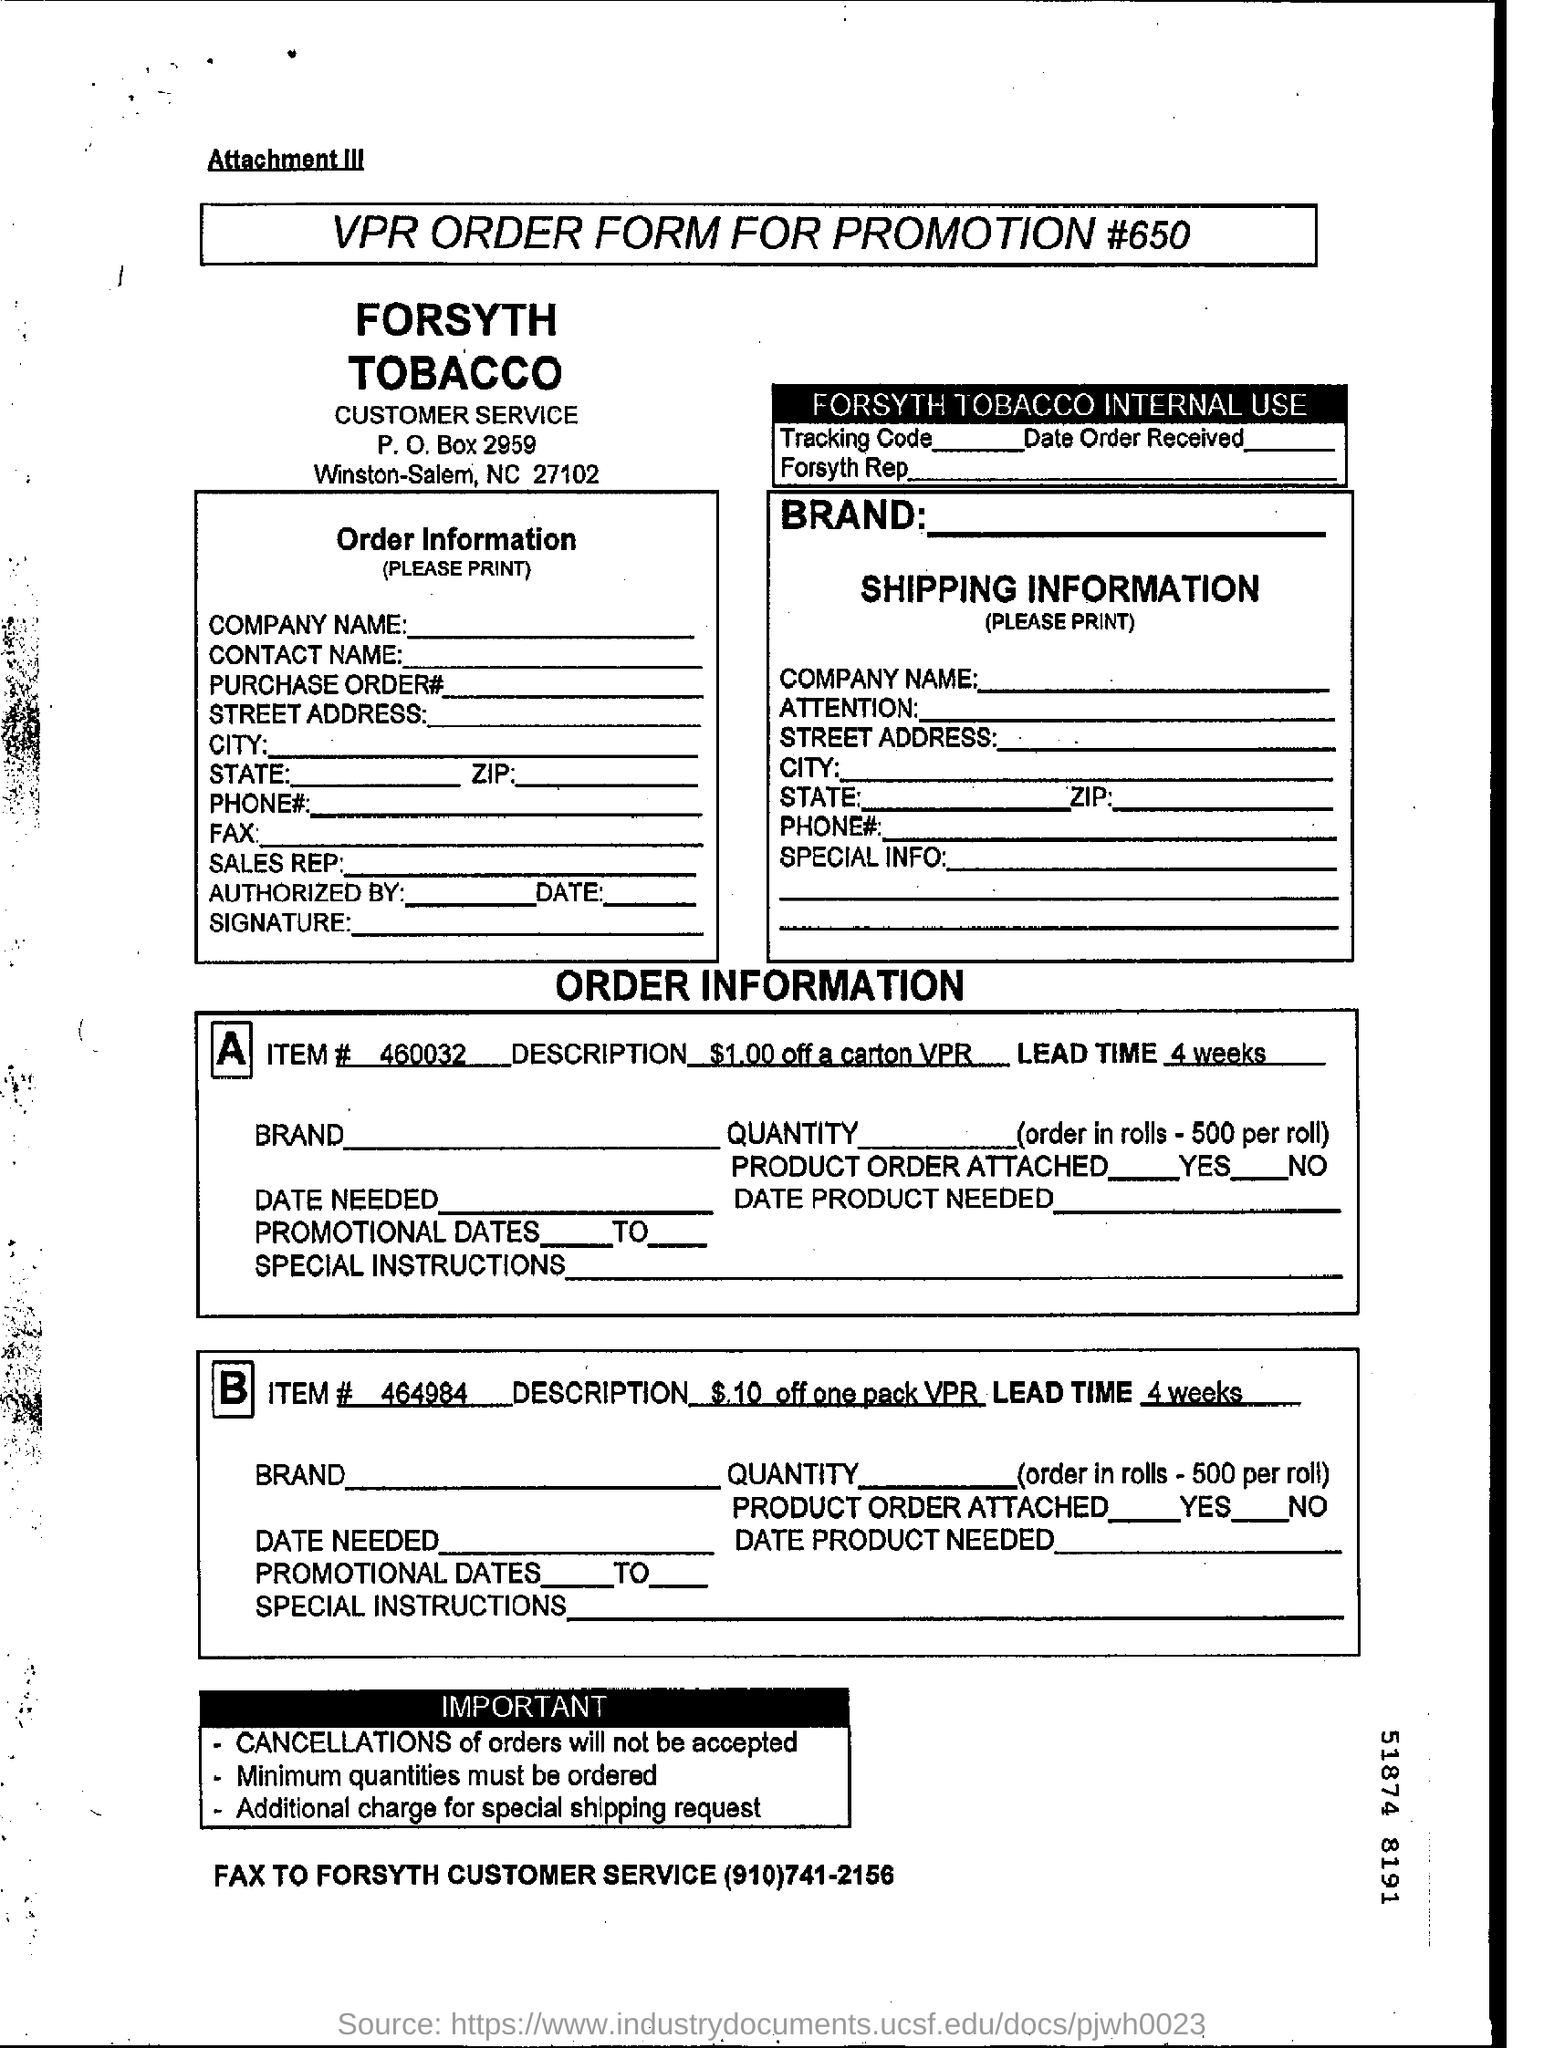Outline some significant characteristics in this image. Item number 460032 is a description of a discount of $1.00 off a carton, with the prefix VPR. The Forsyth customer service fax number is (910)741-2156. The lead time for item #464984 is four weeks. The document title is "What is the VPR ORDER FORM FOR PROMOTION #650?". 